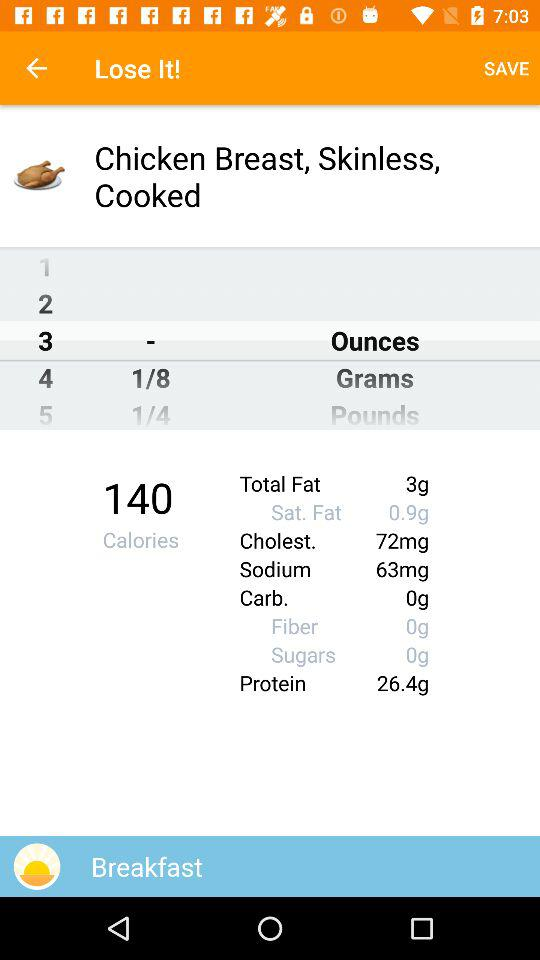How much protein is there? There are 26.4 grams of protein. 